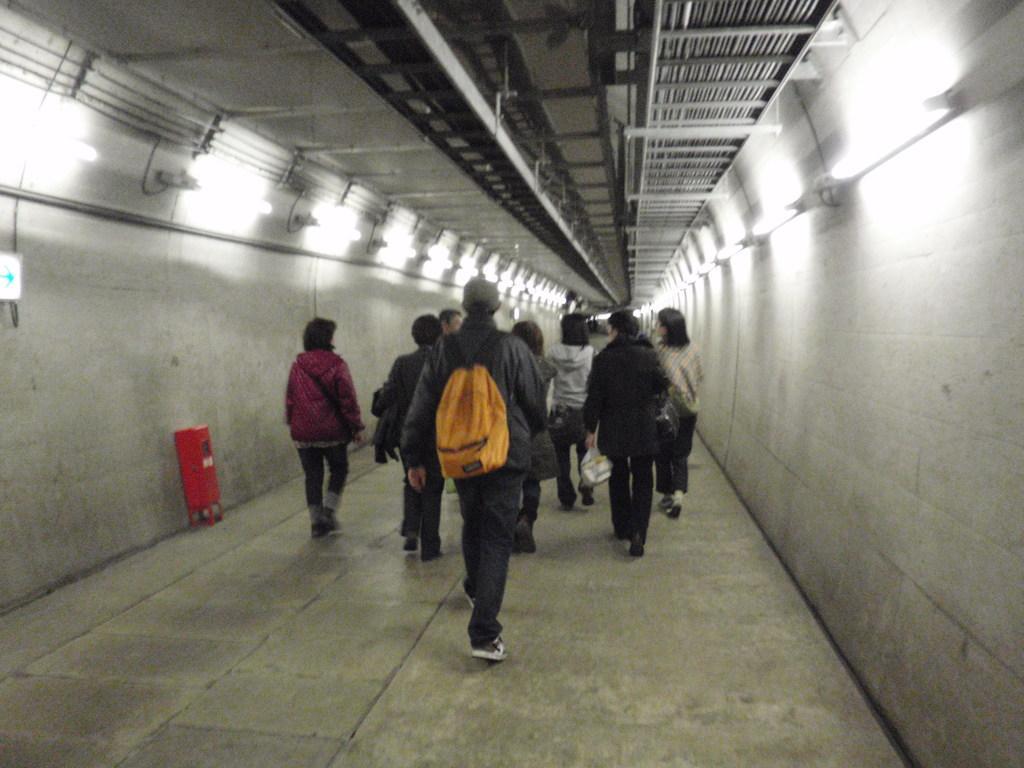Describe this image in one or two sentences. In this picture I can see there are few people walking inside the tunnel and there are lights attached to the tunnel. 